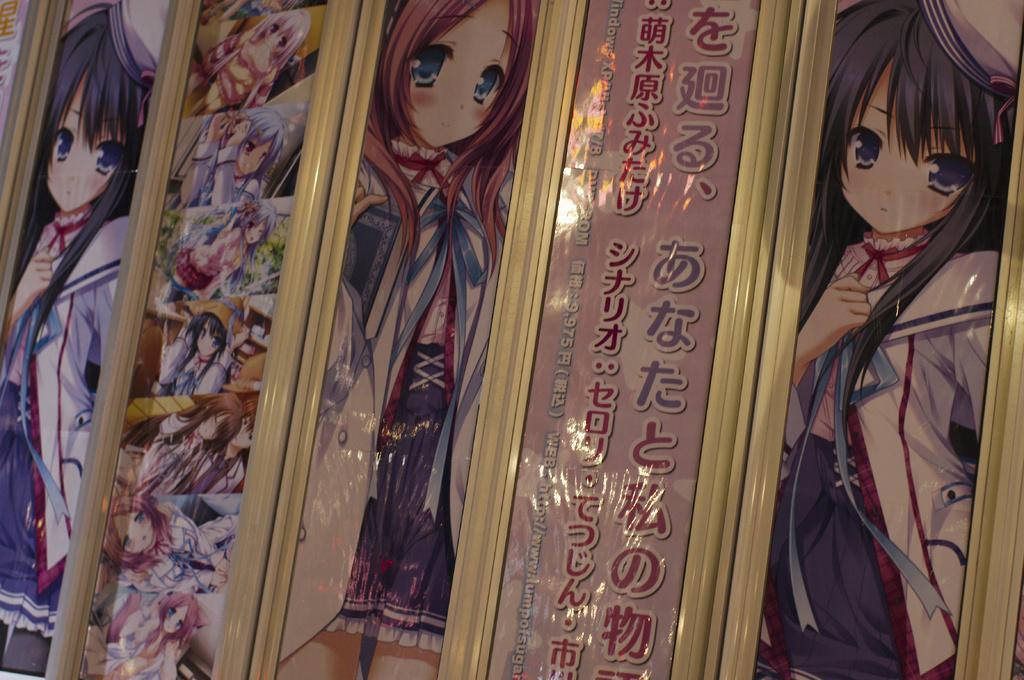Can you describe this image briefly? In the picture there are different animated images of girls printed on the sheets and attached to the doors. 